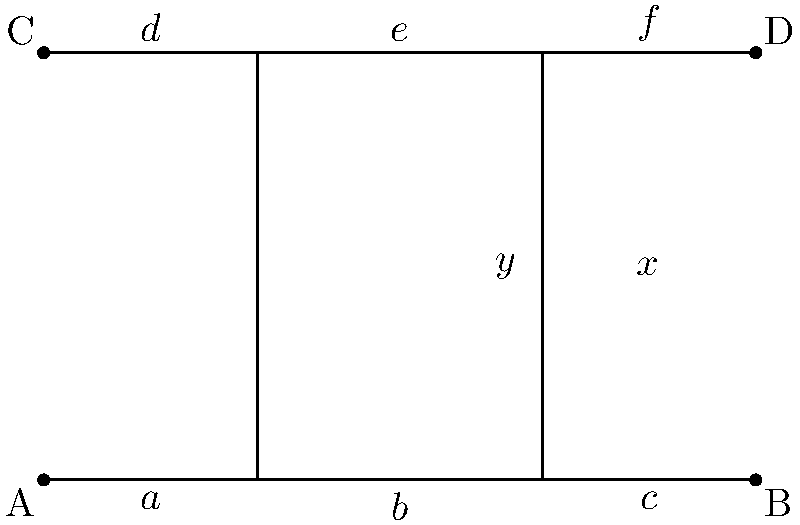As you sort through the day's mail, you come across an intriguing geometry puzzle from a local high school teacher. The puzzle shows two parallel lines cut by two transversals, forming several angles. If $x° = 130°$, what is the value of $y°$? Let's approach this step-by-step:

1) First, recall that when a transversal cuts two parallel lines, corresponding angles are congruent. This means that $x°$ is equal to its corresponding angle on the upper parallel line.

2) Next, remember that angles on a straight line sum to 180°. So, the angle adjacent to $x°$ on the upper line plus $x°$ itself must equal 180°.

3) We can set up an equation:
   $x° + \text{adjacent angle} = 180°$
   $130° + \text{adjacent angle} = 180°$

4) Solving for the adjacent angle:
   $\text{adjacent angle} = 180° - 130° = 50°$

5) Now, notice that this adjacent angle and $y°$ form a pair of alternate interior angles between the parallel lines and the right transversal. Alternate interior angles are congruent.

6) Therefore, $y° = 50°$

This exploration of parallel lines cut by transversals showcases how understanding these properties can lead to solving complex-looking problems with simple steps.
Answer: $50°$ 